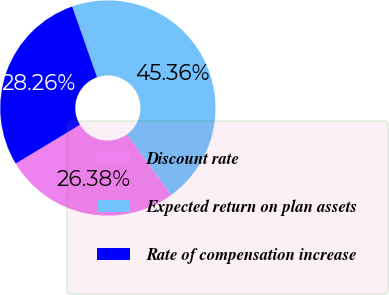Convert chart to OTSL. <chart><loc_0><loc_0><loc_500><loc_500><pie_chart><fcel>Discount rate<fcel>Expected return on plan assets<fcel>Rate of compensation increase<nl><fcel>26.38%<fcel>45.36%<fcel>28.26%<nl></chart> 